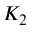Convert formula to latex. <formula><loc_0><loc_0><loc_500><loc_500>K _ { 2 }</formula> 